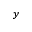Convert formula to latex. <formula><loc_0><loc_0><loc_500><loc_500>y</formula> 